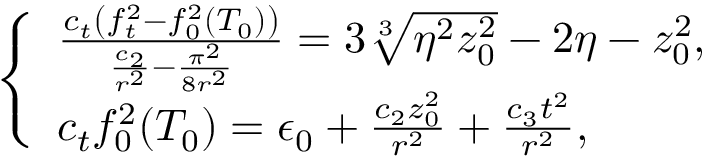<formula> <loc_0><loc_0><loc_500><loc_500>\left \{ \begin{array} { l l } { \frac { c _ { t } \left ( f _ { t } ^ { 2 } - f _ { 0 } ^ { 2 } ( T _ { 0 } ) \right ) } { \frac { c _ { 2 } } { r ^ { 2 } } - \frac { \pi ^ { 2 } } { 8 r ^ { 2 } } } = 3 \sqrt { [ } 3 ] { \eta ^ { 2 } z _ { 0 } ^ { 2 } } - 2 \eta - z _ { 0 } ^ { 2 } , } \\ { c _ { t } f _ { 0 } ^ { 2 } ( T _ { 0 } ) = \epsilon _ { 0 } + \frac { c _ { 2 } z _ { 0 } ^ { 2 } } { r ^ { 2 } } + \frac { c _ { 3 } t ^ { 2 } } { r ^ { 2 } } , } \end{array}</formula> 